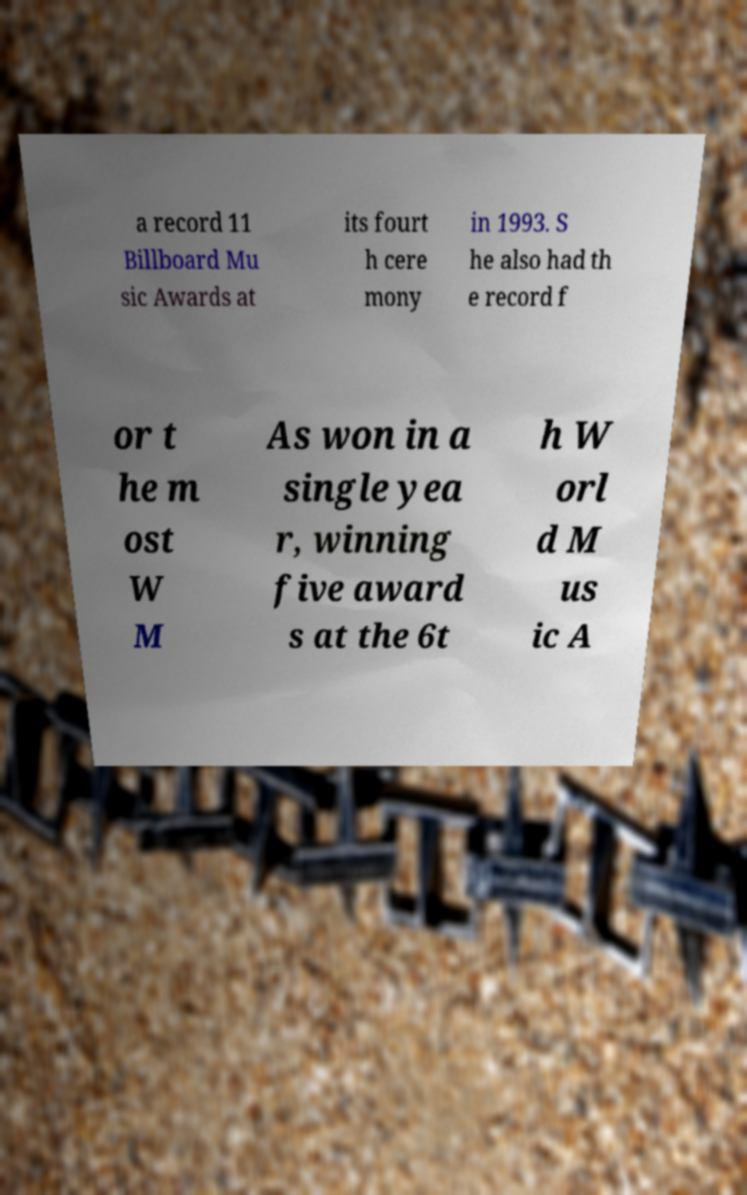I need the written content from this picture converted into text. Can you do that? a record 11 Billboard Mu sic Awards at its fourt h cere mony in 1993. S he also had th e record f or t he m ost W M As won in a single yea r, winning five award s at the 6t h W orl d M us ic A 